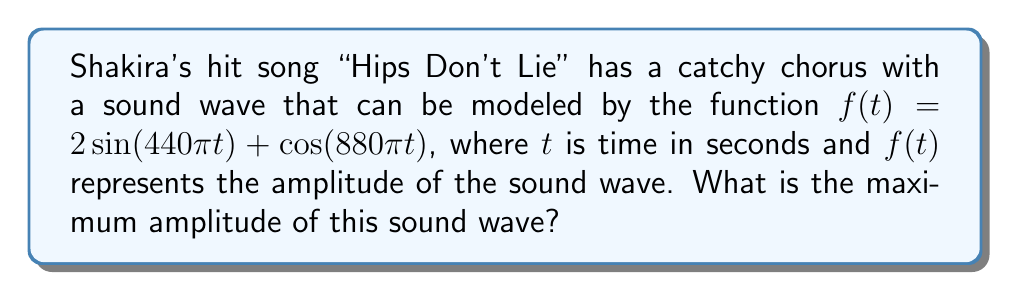Could you help me with this problem? To find the maximum amplitude of the sound wave, we need to follow these steps:

1) The given function is a combination of two trigonometric functions:
   $f(t) = 2\sin(440\pi t) + \cos(880\pi t)$

2) The maximum value of $\sin(x)$ or $\cos(x)$ is always 1, and the minimum is -1.

3) In this case, we have $2\sin(440\pi t)$, so the maximum value of this part is 2 and the minimum is -2.

4) For $\cos(880\pi t)$, the maximum is 1 and the minimum is -1.

5) To find the maximum possible amplitude, we need to consider when both functions are at their maximum:
   $f_{max} = 2 + 1 = 3$

6) The minimum possible value would be when both are at their minimum:
   $f_{min} = -2 - 1 = -3$

7) The amplitude is half the distance between the maximum and minimum values:
   $\text{Amplitude} = \frac{f_{max} - f_{min}}{2} = \frac{3 - (-3)}{2} = \frac{6}{2} = 3$

Therefore, the maximum amplitude of the sound wave is 3.
Answer: 3 